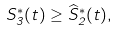Convert formula to latex. <formula><loc_0><loc_0><loc_500><loc_500>S _ { 3 } ^ { * } ( t ) \geq \widehat { S } _ { 2 } ^ { * } ( t ) ,</formula> 